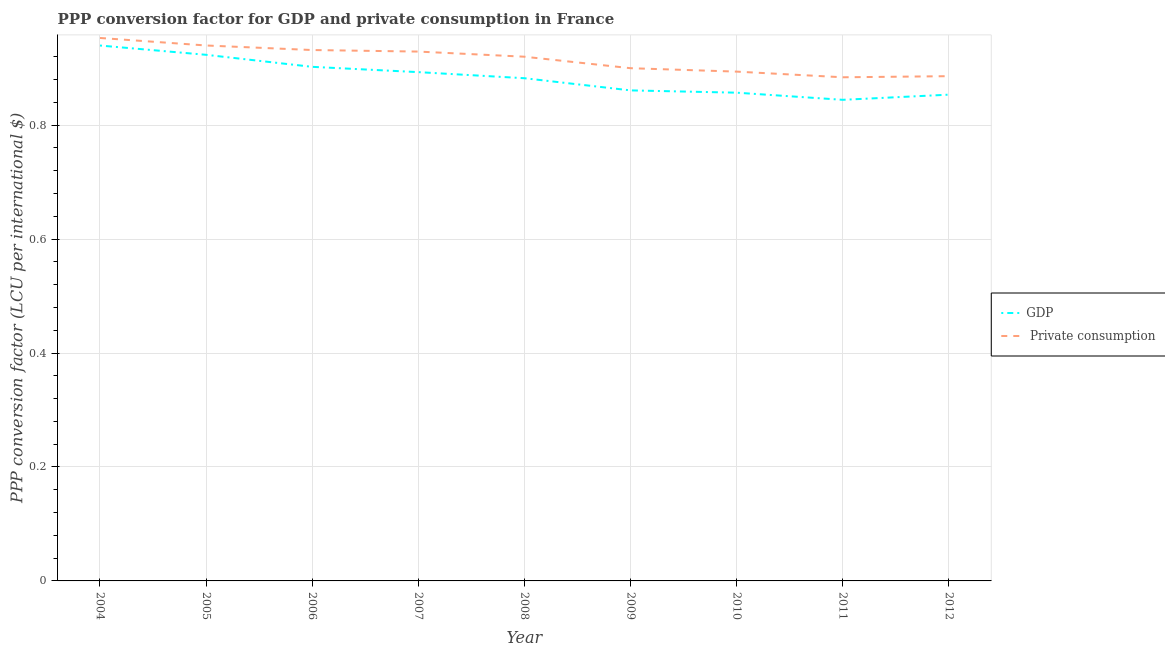Is the number of lines equal to the number of legend labels?
Provide a succinct answer. Yes. What is the ppp conversion factor for gdp in 2012?
Keep it short and to the point. 0.85. Across all years, what is the maximum ppp conversion factor for private consumption?
Give a very brief answer. 0.95. Across all years, what is the minimum ppp conversion factor for gdp?
Keep it short and to the point. 0.84. In which year was the ppp conversion factor for private consumption maximum?
Provide a succinct answer. 2004. What is the total ppp conversion factor for gdp in the graph?
Offer a very short reply. 7.96. What is the difference between the ppp conversion factor for gdp in 2008 and that in 2011?
Offer a very short reply. 0.04. What is the difference between the ppp conversion factor for private consumption in 2004 and the ppp conversion factor for gdp in 2007?
Make the answer very short. 0.06. What is the average ppp conversion factor for gdp per year?
Your answer should be very brief. 0.88. In the year 2009, what is the difference between the ppp conversion factor for private consumption and ppp conversion factor for gdp?
Provide a succinct answer. 0.04. What is the ratio of the ppp conversion factor for private consumption in 2006 to that in 2008?
Offer a terse response. 1.01. Is the ppp conversion factor for private consumption in 2009 less than that in 2010?
Provide a succinct answer. No. Is the difference between the ppp conversion factor for private consumption in 2005 and 2012 greater than the difference between the ppp conversion factor for gdp in 2005 and 2012?
Your response must be concise. No. What is the difference between the highest and the second highest ppp conversion factor for private consumption?
Offer a terse response. 0.01. What is the difference between the highest and the lowest ppp conversion factor for gdp?
Ensure brevity in your answer.  0.1. In how many years, is the ppp conversion factor for private consumption greater than the average ppp conversion factor for private consumption taken over all years?
Your answer should be very brief. 5. Is the ppp conversion factor for private consumption strictly greater than the ppp conversion factor for gdp over the years?
Your answer should be very brief. Yes. Is the ppp conversion factor for private consumption strictly less than the ppp conversion factor for gdp over the years?
Give a very brief answer. No. How many years are there in the graph?
Your answer should be very brief. 9. What is the difference between two consecutive major ticks on the Y-axis?
Keep it short and to the point. 0.2. Are the values on the major ticks of Y-axis written in scientific E-notation?
Your response must be concise. No. Does the graph contain any zero values?
Offer a terse response. No. Does the graph contain grids?
Keep it short and to the point. Yes. Where does the legend appear in the graph?
Your response must be concise. Center right. How many legend labels are there?
Your answer should be compact. 2. What is the title of the graph?
Ensure brevity in your answer.  PPP conversion factor for GDP and private consumption in France. Does "Attending school" appear as one of the legend labels in the graph?
Offer a very short reply. No. What is the label or title of the Y-axis?
Ensure brevity in your answer.  PPP conversion factor (LCU per international $). What is the PPP conversion factor (LCU per international $) in GDP in 2004?
Your answer should be very brief. 0.94. What is the PPP conversion factor (LCU per international $) in  Private consumption in 2004?
Offer a very short reply. 0.95. What is the PPP conversion factor (LCU per international $) in GDP in 2005?
Make the answer very short. 0.92. What is the PPP conversion factor (LCU per international $) of  Private consumption in 2005?
Keep it short and to the point. 0.94. What is the PPP conversion factor (LCU per international $) in GDP in 2006?
Your answer should be very brief. 0.9. What is the PPP conversion factor (LCU per international $) of  Private consumption in 2006?
Provide a succinct answer. 0.93. What is the PPP conversion factor (LCU per international $) in GDP in 2007?
Keep it short and to the point. 0.89. What is the PPP conversion factor (LCU per international $) in  Private consumption in 2007?
Give a very brief answer. 0.93. What is the PPP conversion factor (LCU per international $) in GDP in 2008?
Make the answer very short. 0.88. What is the PPP conversion factor (LCU per international $) in  Private consumption in 2008?
Give a very brief answer. 0.92. What is the PPP conversion factor (LCU per international $) of GDP in 2009?
Offer a terse response. 0.86. What is the PPP conversion factor (LCU per international $) in  Private consumption in 2009?
Your answer should be very brief. 0.9. What is the PPP conversion factor (LCU per international $) of GDP in 2010?
Your answer should be very brief. 0.86. What is the PPP conversion factor (LCU per international $) of  Private consumption in 2010?
Offer a terse response. 0.89. What is the PPP conversion factor (LCU per international $) of GDP in 2011?
Your response must be concise. 0.84. What is the PPP conversion factor (LCU per international $) in  Private consumption in 2011?
Offer a very short reply. 0.88. What is the PPP conversion factor (LCU per international $) in GDP in 2012?
Ensure brevity in your answer.  0.85. What is the PPP conversion factor (LCU per international $) in  Private consumption in 2012?
Your answer should be compact. 0.89. Across all years, what is the maximum PPP conversion factor (LCU per international $) in GDP?
Offer a terse response. 0.94. Across all years, what is the maximum PPP conversion factor (LCU per international $) of  Private consumption?
Give a very brief answer. 0.95. Across all years, what is the minimum PPP conversion factor (LCU per international $) in GDP?
Make the answer very short. 0.84. Across all years, what is the minimum PPP conversion factor (LCU per international $) of  Private consumption?
Provide a succinct answer. 0.88. What is the total PPP conversion factor (LCU per international $) in GDP in the graph?
Keep it short and to the point. 7.96. What is the total PPP conversion factor (LCU per international $) of  Private consumption in the graph?
Make the answer very short. 8.24. What is the difference between the PPP conversion factor (LCU per international $) in GDP in 2004 and that in 2005?
Your response must be concise. 0.02. What is the difference between the PPP conversion factor (LCU per international $) of  Private consumption in 2004 and that in 2005?
Offer a terse response. 0.01. What is the difference between the PPP conversion factor (LCU per international $) in GDP in 2004 and that in 2006?
Ensure brevity in your answer.  0.04. What is the difference between the PPP conversion factor (LCU per international $) in  Private consumption in 2004 and that in 2006?
Keep it short and to the point. 0.02. What is the difference between the PPP conversion factor (LCU per international $) in GDP in 2004 and that in 2007?
Ensure brevity in your answer.  0.05. What is the difference between the PPP conversion factor (LCU per international $) in  Private consumption in 2004 and that in 2007?
Give a very brief answer. 0.02. What is the difference between the PPP conversion factor (LCU per international $) of GDP in 2004 and that in 2008?
Provide a short and direct response. 0.06. What is the difference between the PPP conversion factor (LCU per international $) in  Private consumption in 2004 and that in 2008?
Your response must be concise. 0.03. What is the difference between the PPP conversion factor (LCU per international $) of GDP in 2004 and that in 2009?
Ensure brevity in your answer.  0.08. What is the difference between the PPP conversion factor (LCU per international $) in  Private consumption in 2004 and that in 2009?
Provide a succinct answer. 0.05. What is the difference between the PPP conversion factor (LCU per international $) in GDP in 2004 and that in 2010?
Offer a terse response. 0.08. What is the difference between the PPP conversion factor (LCU per international $) in  Private consumption in 2004 and that in 2010?
Give a very brief answer. 0.06. What is the difference between the PPP conversion factor (LCU per international $) in GDP in 2004 and that in 2011?
Keep it short and to the point. 0.1. What is the difference between the PPP conversion factor (LCU per international $) in  Private consumption in 2004 and that in 2011?
Your response must be concise. 0.07. What is the difference between the PPP conversion factor (LCU per international $) of GDP in 2004 and that in 2012?
Keep it short and to the point. 0.09. What is the difference between the PPP conversion factor (LCU per international $) in  Private consumption in 2004 and that in 2012?
Offer a very short reply. 0.07. What is the difference between the PPP conversion factor (LCU per international $) of GDP in 2005 and that in 2006?
Make the answer very short. 0.02. What is the difference between the PPP conversion factor (LCU per international $) in  Private consumption in 2005 and that in 2006?
Provide a short and direct response. 0.01. What is the difference between the PPP conversion factor (LCU per international $) of GDP in 2005 and that in 2007?
Provide a short and direct response. 0.03. What is the difference between the PPP conversion factor (LCU per international $) in  Private consumption in 2005 and that in 2007?
Your answer should be compact. 0.01. What is the difference between the PPP conversion factor (LCU per international $) of GDP in 2005 and that in 2008?
Provide a succinct answer. 0.04. What is the difference between the PPP conversion factor (LCU per international $) in  Private consumption in 2005 and that in 2008?
Provide a short and direct response. 0.02. What is the difference between the PPP conversion factor (LCU per international $) in GDP in 2005 and that in 2009?
Provide a succinct answer. 0.06. What is the difference between the PPP conversion factor (LCU per international $) in  Private consumption in 2005 and that in 2009?
Provide a short and direct response. 0.04. What is the difference between the PPP conversion factor (LCU per international $) in GDP in 2005 and that in 2010?
Provide a succinct answer. 0.07. What is the difference between the PPP conversion factor (LCU per international $) of  Private consumption in 2005 and that in 2010?
Offer a very short reply. 0.05. What is the difference between the PPP conversion factor (LCU per international $) of GDP in 2005 and that in 2011?
Provide a succinct answer. 0.08. What is the difference between the PPP conversion factor (LCU per international $) of  Private consumption in 2005 and that in 2011?
Your answer should be very brief. 0.06. What is the difference between the PPP conversion factor (LCU per international $) of GDP in 2005 and that in 2012?
Offer a very short reply. 0.07. What is the difference between the PPP conversion factor (LCU per international $) of  Private consumption in 2005 and that in 2012?
Provide a succinct answer. 0.05. What is the difference between the PPP conversion factor (LCU per international $) of GDP in 2006 and that in 2007?
Provide a succinct answer. 0.01. What is the difference between the PPP conversion factor (LCU per international $) in  Private consumption in 2006 and that in 2007?
Your answer should be compact. 0. What is the difference between the PPP conversion factor (LCU per international $) in  Private consumption in 2006 and that in 2008?
Your response must be concise. 0.01. What is the difference between the PPP conversion factor (LCU per international $) of GDP in 2006 and that in 2009?
Your response must be concise. 0.04. What is the difference between the PPP conversion factor (LCU per international $) in  Private consumption in 2006 and that in 2009?
Give a very brief answer. 0.03. What is the difference between the PPP conversion factor (LCU per international $) in GDP in 2006 and that in 2010?
Your response must be concise. 0.05. What is the difference between the PPP conversion factor (LCU per international $) of  Private consumption in 2006 and that in 2010?
Offer a very short reply. 0.04. What is the difference between the PPP conversion factor (LCU per international $) of GDP in 2006 and that in 2011?
Your answer should be very brief. 0.06. What is the difference between the PPP conversion factor (LCU per international $) in  Private consumption in 2006 and that in 2011?
Your response must be concise. 0.05. What is the difference between the PPP conversion factor (LCU per international $) of GDP in 2006 and that in 2012?
Ensure brevity in your answer.  0.05. What is the difference between the PPP conversion factor (LCU per international $) of  Private consumption in 2006 and that in 2012?
Give a very brief answer. 0.05. What is the difference between the PPP conversion factor (LCU per international $) in GDP in 2007 and that in 2008?
Ensure brevity in your answer.  0.01. What is the difference between the PPP conversion factor (LCU per international $) of  Private consumption in 2007 and that in 2008?
Keep it short and to the point. 0.01. What is the difference between the PPP conversion factor (LCU per international $) in GDP in 2007 and that in 2009?
Offer a very short reply. 0.03. What is the difference between the PPP conversion factor (LCU per international $) of  Private consumption in 2007 and that in 2009?
Provide a succinct answer. 0.03. What is the difference between the PPP conversion factor (LCU per international $) in GDP in 2007 and that in 2010?
Your response must be concise. 0.04. What is the difference between the PPP conversion factor (LCU per international $) of  Private consumption in 2007 and that in 2010?
Ensure brevity in your answer.  0.04. What is the difference between the PPP conversion factor (LCU per international $) in GDP in 2007 and that in 2011?
Ensure brevity in your answer.  0.05. What is the difference between the PPP conversion factor (LCU per international $) of  Private consumption in 2007 and that in 2011?
Provide a succinct answer. 0.05. What is the difference between the PPP conversion factor (LCU per international $) of GDP in 2007 and that in 2012?
Make the answer very short. 0.04. What is the difference between the PPP conversion factor (LCU per international $) of  Private consumption in 2007 and that in 2012?
Give a very brief answer. 0.04. What is the difference between the PPP conversion factor (LCU per international $) of GDP in 2008 and that in 2009?
Keep it short and to the point. 0.02. What is the difference between the PPP conversion factor (LCU per international $) in  Private consumption in 2008 and that in 2009?
Your answer should be compact. 0.02. What is the difference between the PPP conversion factor (LCU per international $) of GDP in 2008 and that in 2010?
Offer a terse response. 0.03. What is the difference between the PPP conversion factor (LCU per international $) in  Private consumption in 2008 and that in 2010?
Your answer should be compact. 0.03. What is the difference between the PPP conversion factor (LCU per international $) of GDP in 2008 and that in 2011?
Give a very brief answer. 0.04. What is the difference between the PPP conversion factor (LCU per international $) in  Private consumption in 2008 and that in 2011?
Your answer should be compact. 0.04. What is the difference between the PPP conversion factor (LCU per international $) of GDP in 2008 and that in 2012?
Provide a succinct answer. 0.03. What is the difference between the PPP conversion factor (LCU per international $) in  Private consumption in 2008 and that in 2012?
Your answer should be very brief. 0.03. What is the difference between the PPP conversion factor (LCU per international $) in GDP in 2009 and that in 2010?
Give a very brief answer. 0. What is the difference between the PPP conversion factor (LCU per international $) in  Private consumption in 2009 and that in 2010?
Your response must be concise. 0.01. What is the difference between the PPP conversion factor (LCU per international $) in GDP in 2009 and that in 2011?
Offer a very short reply. 0.02. What is the difference between the PPP conversion factor (LCU per international $) in  Private consumption in 2009 and that in 2011?
Give a very brief answer. 0.02. What is the difference between the PPP conversion factor (LCU per international $) of GDP in 2009 and that in 2012?
Offer a terse response. 0.01. What is the difference between the PPP conversion factor (LCU per international $) of  Private consumption in 2009 and that in 2012?
Make the answer very short. 0.01. What is the difference between the PPP conversion factor (LCU per international $) of GDP in 2010 and that in 2011?
Make the answer very short. 0.01. What is the difference between the PPP conversion factor (LCU per international $) in  Private consumption in 2010 and that in 2011?
Ensure brevity in your answer.  0.01. What is the difference between the PPP conversion factor (LCU per international $) in GDP in 2010 and that in 2012?
Make the answer very short. 0. What is the difference between the PPP conversion factor (LCU per international $) in  Private consumption in 2010 and that in 2012?
Give a very brief answer. 0.01. What is the difference between the PPP conversion factor (LCU per international $) in GDP in 2011 and that in 2012?
Offer a terse response. -0.01. What is the difference between the PPP conversion factor (LCU per international $) in  Private consumption in 2011 and that in 2012?
Your response must be concise. -0. What is the difference between the PPP conversion factor (LCU per international $) in GDP in 2004 and the PPP conversion factor (LCU per international $) in  Private consumption in 2005?
Offer a very short reply. -0. What is the difference between the PPP conversion factor (LCU per international $) of GDP in 2004 and the PPP conversion factor (LCU per international $) of  Private consumption in 2006?
Your response must be concise. 0.01. What is the difference between the PPP conversion factor (LCU per international $) of GDP in 2004 and the PPP conversion factor (LCU per international $) of  Private consumption in 2007?
Offer a very short reply. 0.01. What is the difference between the PPP conversion factor (LCU per international $) in GDP in 2004 and the PPP conversion factor (LCU per international $) in  Private consumption in 2008?
Your response must be concise. 0.02. What is the difference between the PPP conversion factor (LCU per international $) in GDP in 2004 and the PPP conversion factor (LCU per international $) in  Private consumption in 2009?
Provide a short and direct response. 0.04. What is the difference between the PPP conversion factor (LCU per international $) in GDP in 2004 and the PPP conversion factor (LCU per international $) in  Private consumption in 2010?
Offer a very short reply. 0.05. What is the difference between the PPP conversion factor (LCU per international $) in GDP in 2004 and the PPP conversion factor (LCU per international $) in  Private consumption in 2011?
Make the answer very short. 0.06. What is the difference between the PPP conversion factor (LCU per international $) in GDP in 2004 and the PPP conversion factor (LCU per international $) in  Private consumption in 2012?
Provide a short and direct response. 0.05. What is the difference between the PPP conversion factor (LCU per international $) of GDP in 2005 and the PPP conversion factor (LCU per international $) of  Private consumption in 2006?
Your response must be concise. -0.01. What is the difference between the PPP conversion factor (LCU per international $) in GDP in 2005 and the PPP conversion factor (LCU per international $) in  Private consumption in 2007?
Offer a terse response. -0.01. What is the difference between the PPP conversion factor (LCU per international $) in GDP in 2005 and the PPP conversion factor (LCU per international $) in  Private consumption in 2008?
Offer a very short reply. 0. What is the difference between the PPP conversion factor (LCU per international $) in GDP in 2005 and the PPP conversion factor (LCU per international $) in  Private consumption in 2009?
Ensure brevity in your answer.  0.02. What is the difference between the PPP conversion factor (LCU per international $) in GDP in 2005 and the PPP conversion factor (LCU per international $) in  Private consumption in 2010?
Your answer should be very brief. 0.03. What is the difference between the PPP conversion factor (LCU per international $) in GDP in 2005 and the PPP conversion factor (LCU per international $) in  Private consumption in 2011?
Keep it short and to the point. 0.04. What is the difference between the PPP conversion factor (LCU per international $) of GDP in 2005 and the PPP conversion factor (LCU per international $) of  Private consumption in 2012?
Provide a succinct answer. 0.04. What is the difference between the PPP conversion factor (LCU per international $) of GDP in 2006 and the PPP conversion factor (LCU per international $) of  Private consumption in 2007?
Ensure brevity in your answer.  -0.03. What is the difference between the PPP conversion factor (LCU per international $) in GDP in 2006 and the PPP conversion factor (LCU per international $) in  Private consumption in 2008?
Provide a succinct answer. -0.02. What is the difference between the PPP conversion factor (LCU per international $) in GDP in 2006 and the PPP conversion factor (LCU per international $) in  Private consumption in 2009?
Ensure brevity in your answer.  0. What is the difference between the PPP conversion factor (LCU per international $) of GDP in 2006 and the PPP conversion factor (LCU per international $) of  Private consumption in 2010?
Provide a short and direct response. 0.01. What is the difference between the PPP conversion factor (LCU per international $) of GDP in 2006 and the PPP conversion factor (LCU per international $) of  Private consumption in 2011?
Offer a terse response. 0.02. What is the difference between the PPP conversion factor (LCU per international $) in GDP in 2006 and the PPP conversion factor (LCU per international $) in  Private consumption in 2012?
Your answer should be very brief. 0.02. What is the difference between the PPP conversion factor (LCU per international $) in GDP in 2007 and the PPP conversion factor (LCU per international $) in  Private consumption in 2008?
Offer a very short reply. -0.03. What is the difference between the PPP conversion factor (LCU per international $) of GDP in 2007 and the PPP conversion factor (LCU per international $) of  Private consumption in 2009?
Give a very brief answer. -0.01. What is the difference between the PPP conversion factor (LCU per international $) of GDP in 2007 and the PPP conversion factor (LCU per international $) of  Private consumption in 2010?
Keep it short and to the point. -0. What is the difference between the PPP conversion factor (LCU per international $) of GDP in 2007 and the PPP conversion factor (LCU per international $) of  Private consumption in 2011?
Provide a short and direct response. 0.01. What is the difference between the PPP conversion factor (LCU per international $) in GDP in 2007 and the PPP conversion factor (LCU per international $) in  Private consumption in 2012?
Your answer should be very brief. 0.01. What is the difference between the PPP conversion factor (LCU per international $) in GDP in 2008 and the PPP conversion factor (LCU per international $) in  Private consumption in 2009?
Make the answer very short. -0.02. What is the difference between the PPP conversion factor (LCU per international $) of GDP in 2008 and the PPP conversion factor (LCU per international $) of  Private consumption in 2010?
Give a very brief answer. -0.01. What is the difference between the PPP conversion factor (LCU per international $) in GDP in 2008 and the PPP conversion factor (LCU per international $) in  Private consumption in 2011?
Ensure brevity in your answer.  -0. What is the difference between the PPP conversion factor (LCU per international $) in GDP in 2008 and the PPP conversion factor (LCU per international $) in  Private consumption in 2012?
Give a very brief answer. -0. What is the difference between the PPP conversion factor (LCU per international $) in GDP in 2009 and the PPP conversion factor (LCU per international $) in  Private consumption in 2010?
Make the answer very short. -0.03. What is the difference between the PPP conversion factor (LCU per international $) in GDP in 2009 and the PPP conversion factor (LCU per international $) in  Private consumption in 2011?
Offer a terse response. -0.02. What is the difference between the PPP conversion factor (LCU per international $) in GDP in 2009 and the PPP conversion factor (LCU per international $) in  Private consumption in 2012?
Make the answer very short. -0.03. What is the difference between the PPP conversion factor (LCU per international $) of GDP in 2010 and the PPP conversion factor (LCU per international $) of  Private consumption in 2011?
Provide a succinct answer. -0.03. What is the difference between the PPP conversion factor (LCU per international $) in GDP in 2010 and the PPP conversion factor (LCU per international $) in  Private consumption in 2012?
Offer a very short reply. -0.03. What is the difference between the PPP conversion factor (LCU per international $) in GDP in 2011 and the PPP conversion factor (LCU per international $) in  Private consumption in 2012?
Offer a terse response. -0.04. What is the average PPP conversion factor (LCU per international $) in GDP per year?
Provide a short and direct response. 0.88. What is the average PPP conversion factor (LCU per international $) of  Private consumption per year?
Your response must be concise. 0.92. In the year 2004, what is the difference between the PPP conversion factor (LCU per international $) of GDP and PPP conversion factor (LCU per international $) of  Private consumption?
Keep it short and to the point. -0.01. In the year 2005, what is the difference between the PPP conversion factor (LCU per international $) of GDP and PPP conversion factor (LCU per international $) of  Private consumption?
Provide a succinct answer. -0.02. In the year 2006, what is the difference between the PPP conversion factor (LCU per international $) in GDP and PPP conversion factor (LCU per international $) in  Private consumption?
Make the answer very short. -0.03. In the year 2007, what is the difference between the PPP conversion factor (LCU per international $) in GDP and PPP conversion factor (LCU per international $) in  Private consumption?
Your response must be concise. -0.04. In the year 2008, what is the difference between the PPP conversion factor (LCU per international $) in GDP and PPP conversion factor (LCU per international $) in  Private consumption?
Your answer should be very brief. -0.04. In the year 2009, what is the difference between the PPP conversion factor (LCU per international $) of GDP and PPP conversion factor (LCU per international $) of  Private consumption?
Give a very brief answer. -0.04. In the year 2010, what is the difference between the PPP conversion factor (LCU per international $) of GDP and PPP conversion factor (LCU per international $) of  Private consumption?
Provide a short and direct response. -0.04. In the year 2011, what is the difference between the PPP conversion factor (LCU per international $) in GDP and PPP conversion factor (LCU per international $) in  Private consumption?
Ensure brevity in your answer.  -0.04. In the year 2012, what is the difference between the PPP conversion factor (LCU per international $) of GDP and PPP conversion factor (LCU per international $) of  Private consumption?
Make the answer very short. -0.03. What is the ratio of the PPP conversion factor (LCU per international $) in GDP in 2004 to that in 2005?
Give a very brief answer. 1.02. What is the ratio of the PPP conversion factor (LCU per international $) in  Private consumption in 2004 to that in 2005?
Offer a very short reply. 1.01. What is the ratio of the PPP conversion factor (LCU per international $) of GDP in 2004 to that in 2006?
Ensure brevity in your answer.  1.04. What is the ratio of the PPP conversion factor (LCU per international $) of  Private consumption in 2004 to that in 2006?
Your answer should be very brief. 1.02. What is the ratio of the PPP conversion factor (LCU per international $) of GDP in 2004 to that in 2007?
Ensure brevity in your answer.  1.05. What is the ratio of the PPP conversion factor (LCU per international $) in  Private consumption in 2004 to that in 2007?
Your answer should be very brief. 1.03. What is the ratio of the PPP conversion factor (LCU per international $) of GDP in 2004 to that in 2008?
Your response must be concise. 1.06. What is the ratio of the PPP conversion factor (LCU per international $) of  Private consumption in 2004 to that in 2008?
Your answer should be compact. 1.04. What is the ratio of the PPP conversion factor (LCU per international $) of GDP in 2004 to that in 2009?
Offer a terse response. 1.09. What is the ratio of the PPP conversion factor (LCU per international $) in  Private consumption in 2004 to that in 2009?
Keep it short and to the point. 1.06. What is the ratio of the PPP conversion factor (LCU per international $) of GDP in 2004 to that in 2010?
Offer a very short reply. 1.1. What is the ratio of the PPP conversion factor (LCU per international $) in  Private consumption in 2004 to that in 2010?
Your answer should be compact. 1.07. What is the ratio of the PPP conversion factor (LCU per international $) of GDP in 2004 to that in 2011?
Keep it short and to the point. 1.11. What is the ratio of the PPP conversion factor (LCU per international $) of  Private consumption in 2004 to that in 2011?
Give a very brief answer. 1.08. What is the ratio of the PPP conversion factor (LCU per international $) of GDP in 2004 to that in 2012?
Provide a short and direct response. 1.1. What is the ratio of the PPP conversion factor (LCU per international $) of  Private consumption in 2004 to that in 2012?
Your response must be concise. 1.08. What is the ratio of the PPP conversion factor (LCU per international $) of GDP in 2005 to that in 2006?
Provide a short and direct response. 1.02. What is the ratio of the PPP conversion factor (LCU per international $) in  Private consumption in 2005 to that in 2006?
Your answer should be compact. 1.01. What is the ratio of the PPP conversion factor (LCU per international $) in GDP in 2005 to that in 2007?
Offer a very short reply. 1.03. What is the ratio of the PPP conversion factor (LCU per international $) of  Private consumption in 2005 to that in 2007?
Your answer should be compact. 1.01. What is the ratio of the PPP conversion factor (LCU per international $) of GDP in 2005 to that in 2008?
Make the answer very short. 1.05. What is the ratio of the PPP conversion factor (LCU per international $) in  Private consumption in 2005 to that in 2008?
Your response must be concise. 1.02. What is the ratio of the PPP conversion factor (LCU per international $) in GDP in 2005 to that in 2009?
Your answer should be very brief. 1.07. What is the ratio of the PPP conversion factor (LCU per international $) in  Private consumption in 2005 to that in 2009?
Give a very brief answer. 1.04. What is the ratio of the PPP conversion factor (LCU per international $) in GDP in 2005 to that in 2010?
Offer a very short reply. 1.08. What is the ratio of the PPP conversion factor (LCU per international $) of  Private consumption in 2005 to that in 2010?
Your response must be concise. 1.05. What is the ratio of the PPP conversion factor (LCU per international $) of GDP in 2005 to that in 2011?
Your answer should be very brief. 1.09. What is the ratio of the PPP conversion factor (LCU per international $) in  Private consumption in 2005 to that in 2011?
Offer a very short reply. 1.06. What is the ratio of the PPP conversion factor (LCU per international $) of GDP in 2005 to that in 2012?
Your response must be concise. 1.08. What is the ratio of the PPP conversion factor (LCU per international $) of  Private consumption in 2005 to that in 2012?
Offer a terse response. 1.06. What is the ratio of the PPP conversion factor (LCU per international $) of GDP in 2006 to that in 2007?
Make the answer very short. 1.01. What is the ratio of the PPP conversion factor (LCU per international $) in  Private consumption in 2006 to that in 2007?
Your response must be concise. 1. What is the ratio of the PPP conversion factor (LCU per international $) in GDP in 2006 to that in 2008?
Offer a very short reply. 1.02. What is the ratio of the PPP conversion factor (LCU per international $) in  Private consumption in 2006 to that in 2008?
Make the answer very short. 1.01. What is the ratio of the PPP conversion factor (LCU per international $) of GDP in 2006 to that in 2009?
Your answer should be compact. 1.05. What is the ratio of the PPP conversion factor (LCU per international $) of  Private consumption in 2006 to that in 2009?
Make the answer very short. 1.04. What is the ratio of the PPP conversion factor (LCU per international $) of GDP in 2006 to that in 2010?
Give a very brief answer. 1.05. What is the ratio of the PPP conversion factor (LCU per international $) of  Private consumption in 2006 to that in 2010?
Provide a short and direct response. 1.04. What is the ratio of the PPP conversion factor (LCU per international $) of GDP in 2006 to that in 2011?
Keep it short and to the point. 1.07. What is the ratio of the PPP conversion factor (LCU per international $) in  Private consumption in 2006 to that in 2011?
Your answer should be very brief. 1.05. What is the ratio of the PPP conversion factor (LCU per international $) in GDP in 2006 to that in 2012?
Your response must be concise. 1.06. What is the ratio of the PPP conversion factor (LCU per international $) of  Private consumption in 2006 to that in 2012?
Offer a terse response. 1.05. What is the ratio of the PPP conversion factor (LCU per international $) of GDP in 2007 to that in 2008?
Provide a short and direct response. 1.01. What is the ratio of the PPP conversion factor (LCU per international $) in  Private consumption in 2007 to that in 2008?
Offer a terse response. 1.01. What is the ratio of the PPP conversion factor (LCU per international $) in GDP in 2007 to that in 2009?
Your answer should be compact. 1.04. What is the ratio of the PPP conversion factor (LCU per international $) of  Private consumption in 2007 to that in 2009?
Offer a very short reply. 1.03. What is the ratio of the PPP conversion factor (LCU per international $) of GDP in 2007 to that in 2010?
Give a very brief answer. 1.04. What is the ratio of the PPP conversion factor (LCU per international $) of  Private consumption in 2007 to that in 2010?
Your response must be concise. 1.04. What is the ratio of the PPP conversion factor (LCU per international $) in GDP in 2007 to that in 2011?
Offer a terse response. 1.06. What is the ratio of the PPP conversion factor (LCU per international $) in  Private consumption in 2007 to that in 2011?
Provide a succinct answer. 1.05. What is the ratio of the PPP conversion factor (LCU per international $) in GDP in 2007 to that in 2012?
Ensure brevity in your answer.  1.05. What is the ratio of the PPP conversion factor (LCU per international $) in  Private consumption in 2007 to that in 2012?
Keep it short and to the point. 1.05. What is the ratio of the PPP conversion factor (LCU per international $) of GDP in 2008 to that in 2009?
Give a very brief answer. 1.02. What is the ratio of the PPP conversion factor (LCU per international $) of  Private consumption in 2008 to that in 2009?
Offer a very short reply. 1.02. What is the ratio of the PPP conversion factor (LCU per international $) of GDP in 2008 to that in 2010?
Your answer should be compact. 1.03. What is the ratio of the PPP conversion factor (LCU per international $) in  Private consumption in 2008 to that in 2010?
Give a very brief answer. 1.03. What is the ratio of the PPP conversion factor (LCU per international $) of GDP in 2008 to that in 2011?
Give a very brief answer. 1.04. What is the ratio of the PPP conversion factor (LCU per international $) in  Private consumption in 2008 to that in 2011?
Your response must be concise. 1.04. What is the ratio of the PPP conversion factor (LCU per international $) of GDP in 2008 to that in 2012?
Your answer should be compact. 1.03. What is the ratio of the PPP conversion factor (LCU per international $) of  Private consumption in 2008 to that in 2012?
Provide a succinct answer. 1.04. What is the ratio of the PPP conversion factor (LCU per international $) in GDP in 2009 to that in 2010?
Your answer should be compact. 1. What is the ratio of the PPP conversion factor (LCU per international $) in  Private consumption in 2009 to that in 2010?
Offer a very short reply. 1.01. What is the ratio of the PPP conversion factor (LCU per international $) of GDP in 2009 to that in 2011?
Offer a very short reply. 1.02. What is the ratio of the PPP conversion factor (LCU per international $) of GDP in 2009 to that in 2012?
Your answer should be very brief. 1.01. What is the ratio of the PPP conversion factor (LCU per international $) of  Private consumption in 2009 to that in 2012?
Provide a short and direct response. 1.02. What is the ratio of the PPP conversion factor (LCU per international $) of GDP in 2010 to that in 2011?
Keep it short and to the point. 1.01. What is the ratio of the PPP conversion factor (LCU per international $) of  Private consumption in 2010 to that in 2011?
Your answer should be very brief. 1.01. What is the ratio of the PPP conversion factor (LCU per international $) of GDP in 2010 to that in 2012?
Make the answer very short. 1. What is the ratio of the PPP conversion factor (LCU per international $) in  Private consumption in 2010 to that in 2012?
Give a very brief answer. 1.01. What is the ratio of the PPP conversion factor (LCU per international $) in  Private consumption in 2011 to that in 2012?
Make the answer very short. 1. What is the difference between the highest and the second highest PPP conversion factor (LCU per international $) in GDP?
Provide a succinct answer. 0.02. What is the difference between the highest and the second highest PPP conversion factor (LCU per international $) in  Private consumption?
Ensure brevity in your answer.  0.01. What is the difference between the highest and the lowest PPP conversion factor (LCU per international $) of GDP?
Keep it short and to the point. 0.1. What is the difference between the highest and the lowest PPP conversion factor (LCU per international $) in  Private consumption?
Offer a very short reply. 0.07. 